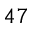Convert formula to latex. <formula><loc_0><loc_0><loc_500><loc_500>^ { 4 7 }</formula> 